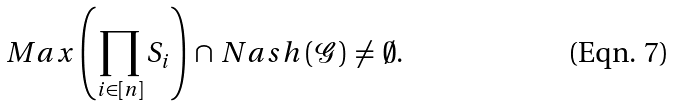<formula> <loc_0><loc_0><loc_500><loc_500>M a x \left ( \prod _ { i \in [ n ] } S _ { i } \right ) \, \cap \, N a s h \left ( { \mathcal { G } } \right ) \, \neq \, \emptyset .</formula> 